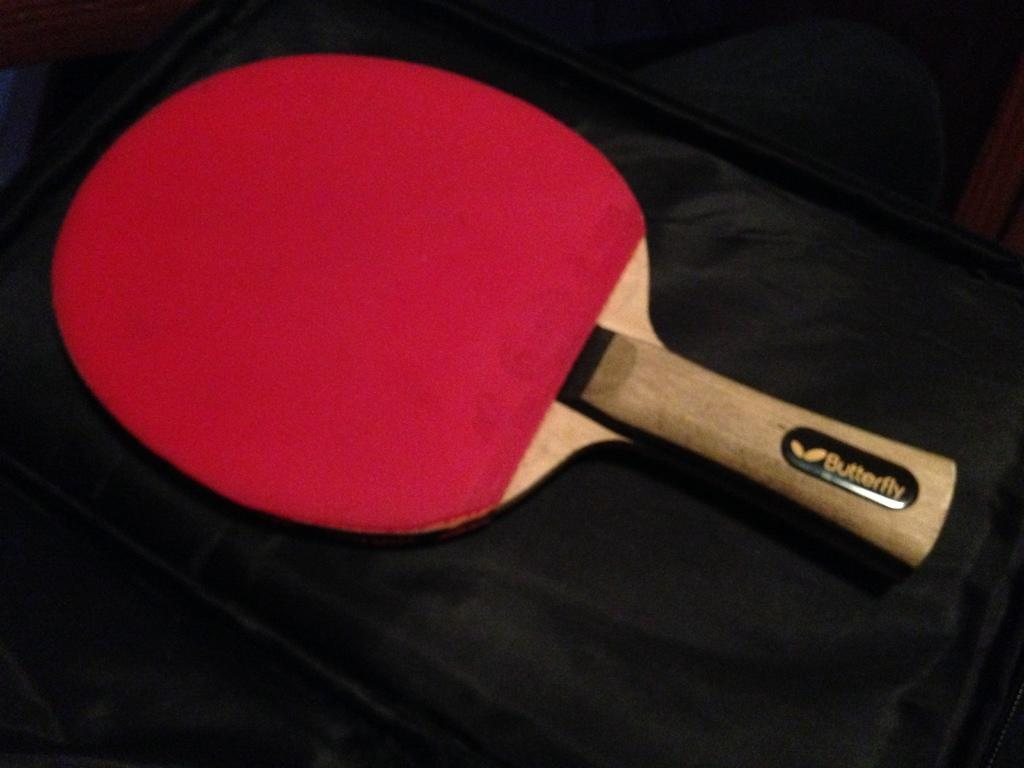What is the main subject of the image? The main subject of the image is a bat. Can you describe the colors of the bat? The bat is red and cream in color. Is there any text present on the bat? Yes, there is text written on the bat. What is the color of the background in the image? The background of the image is black. What type of paste is being used to hold the oranges together in the image? There are no oranges present in the image, and therefore no paste or any related activity can be observed. 